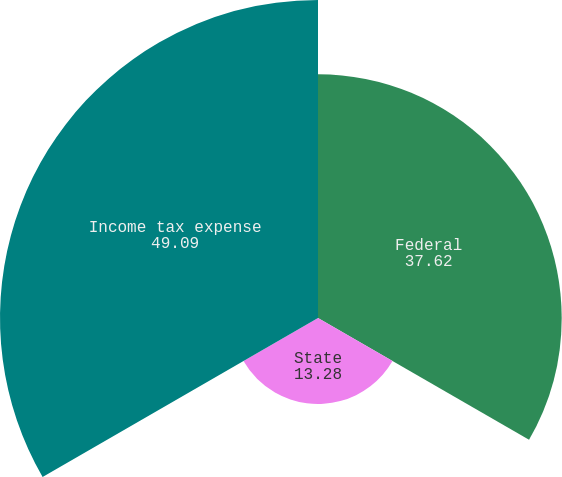Convert chart to OTSL. <chart><loc_0><loc_0><loc_500><loc_500><pie_chart><fcel>Federal<fcel>State<fcel>Income tax expense<nl><fcel>37.62%<fcel>13.28%<fcel>49.09%<nl></chart> 